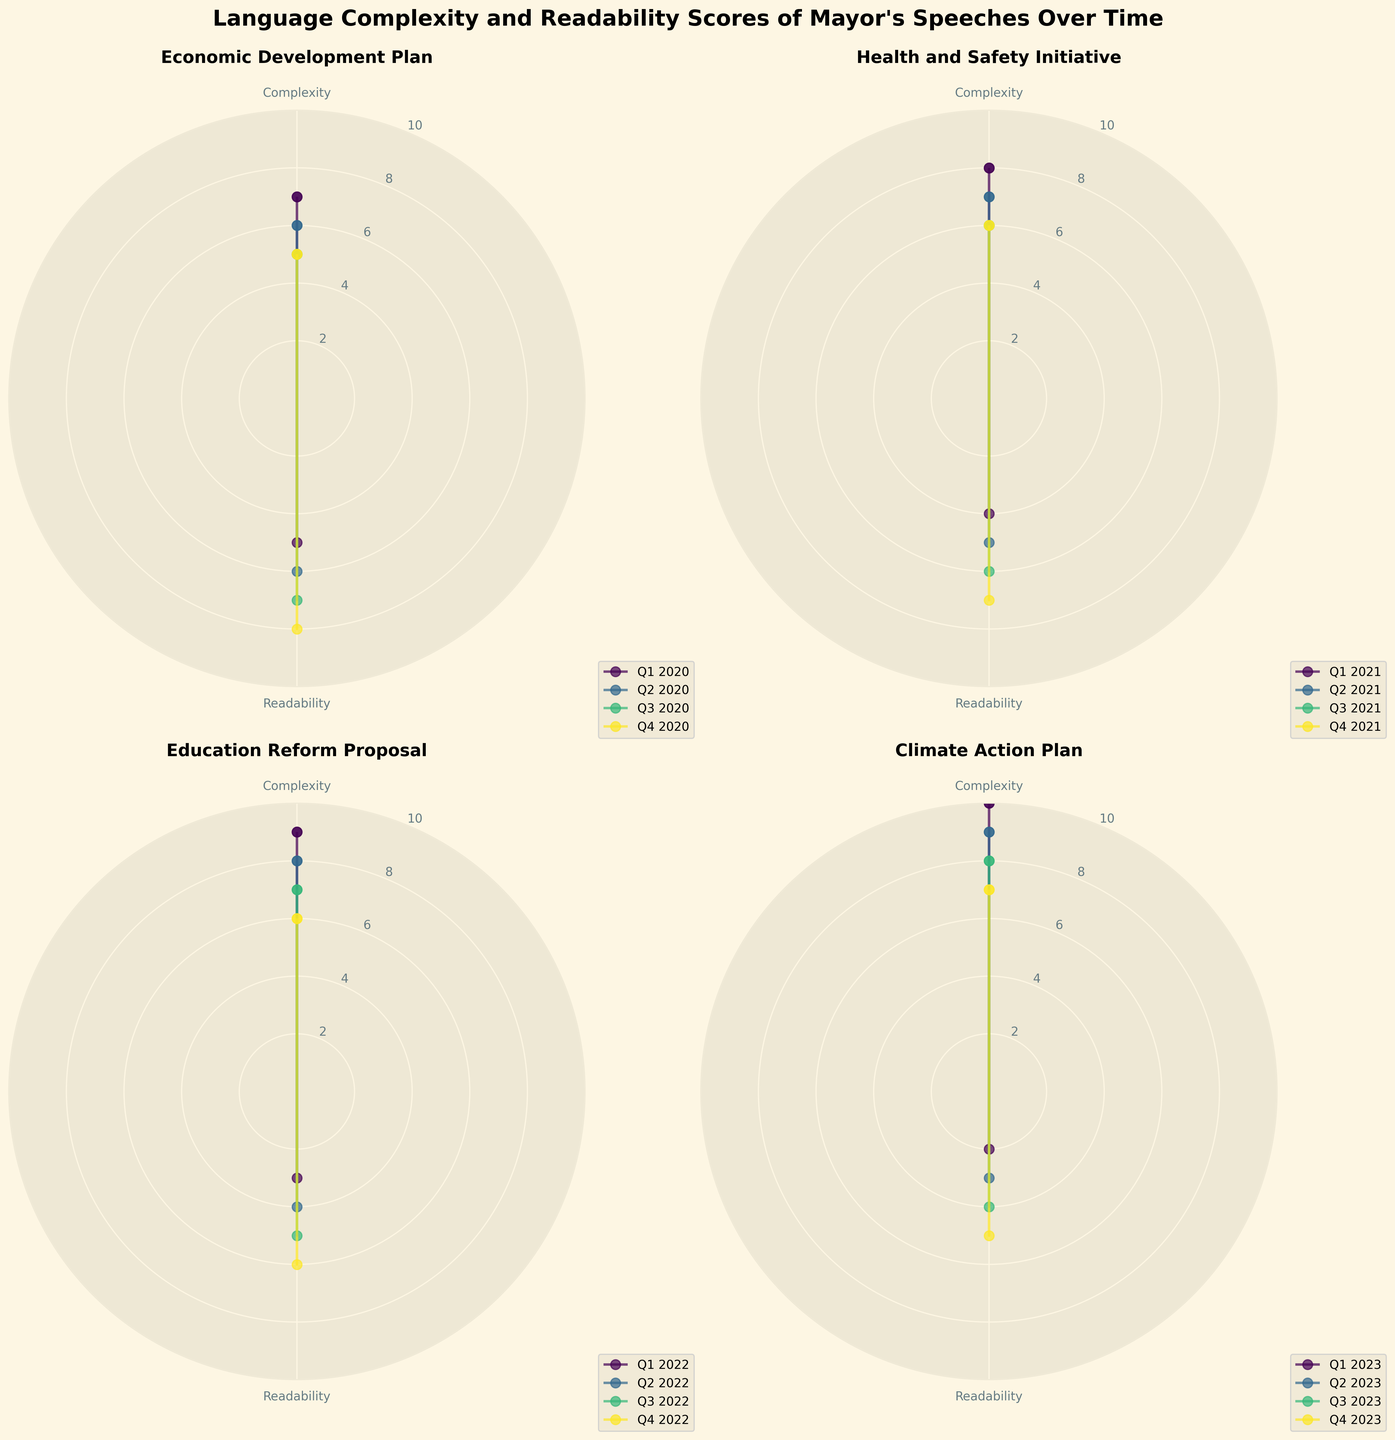Which speech has the highest Complexity score? From the radar charts, the Complexity scores are compared for each speech. The highest score is in the Climate Action Plan radar where the peak is at 10 in Q1 2023.
Answer: Climate Action Plan Which quarter shows the highest increase in Readability for the Economic Development Plan? By looking at the Readability scores in the Economic Development Plan radar, we can see that there is an increase every quarter. The highest jump happens between Q1 2020 (5) and Q2 2020 (6).
Answer: Q2 2020 What is the average Complexity score for the Health and Safety Initiative? Adding up all the Complexity scores for the Health and Safety Initiative (8, 7, 6, 6) and dividing by the number of quarters (4) gives the average. Calculation: (8 + 7 + 6 + 6) / 4 = 6.75.
Answer: 6.75 How does the Readability score in Q1 2022 for the Education Reform Proposal compare with Q1 2023 for the Climate Action Plan? Both radar charts show Readability values. For Q1 2022 in the Education Reform Proposal, the score is 3. In Q1 2023 for the Climate Action Plan, it is 2. This indicates that Q1 2022 has a higher Readability score.
Answer: Q1 2022 is higher Over the entire period, which speech shows the most consistent Complexity score? To determine consistency, the radar charts for each speech are evaluated for variability in Complexity scores. The Economic Development Plan has the least variability (scores of 7, 6, 5, 5) compared to other speeches.
Answer: Economic Development Plan Which speech had the highest Readability score in any quarter? All Readability scores across the radar charts need to be examined. The highest Readability score is 8 found in Q4 2020 of the Economic Development Plan.
Answer: Economic Development Plan in Q4 2020 Is there any quarter where both the Complexity and Readability scores are equal? By checking each quarter in all radar charts, we find that in Q2 2020 of the Economic Development Plan, both scores are 6.
Answer: Q2 2020 in Economic Development Plan Which speech has the steepest decline in Complexity scores from the start to end date? The radar charts show the start and end Complexity scores for each speech. The Climate Action Plan starts at 10 and ends at 7, showing a decline of 3 units, which is the steepest compared to other speeches.
Answer: Climate Action Plan What is the trend in Readability scores for the Health and Safety Initiative from 2021 to Q4 2021? Reviewing the Readability scores in the radar chart for Health and Safety Initiative, we see a steady increase: Q1 2021 (4), Q2 2021 (5), Q3 2021 (6), Q4 2021 (7).
Answer: Increasing 